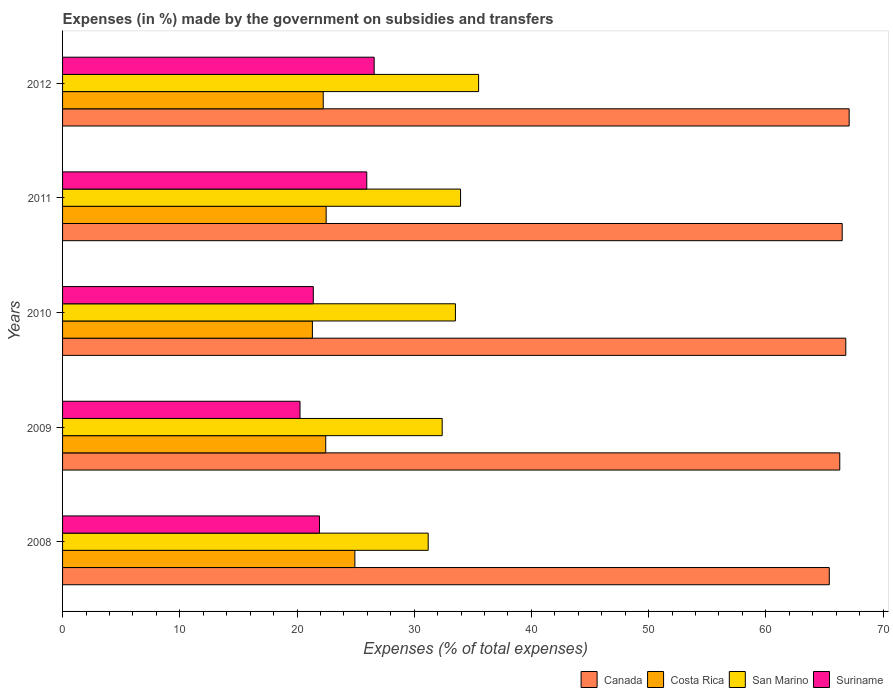How many different coloured bars are there?
Provide a succinct answer. 4. How many groups of bars are there?
Keep it short and to the point. 5. Are the number of bars per tick equal to the number of legend labels?
Keep it short and to the point. Yes. How many bars are there on the 1st tick from the bottom?
Give a very brief answer. 4. What is the percentage of expenses made by the government on subsidies and transfers in Canada in 2008?
Provide a succinct answer. 65.41. Across all years, what is the maximum percentage of expenses made by the government on subsidies and transfers in Suriname?
Provide a short and direct response. 26.58. Across all years, what is the minimum percentage of expenses made by the government on subsidies and transfers in Costa Rica?
Your answer should be very brief. 21.31. What is the total percentage of expenses made by the government on subsidies and transfers in San Marino in the graph?
Provide a succinct answer. 166.54. What is the difference between the percentage of expenses made by the government on subsidies and transfers in Costa Rica in 2011 and that in 2012?
Make the answer very short. 0.25. What is the difference between the percentage of expenses made by the government on subsidies and transfers in Canada in 2010 and the percentage of expenses made by the government on subsidies and transfers in San Marino in 2011?
Keep it short and to the point. 32.86. What is the average percentage of expenses made by the government on subsidies and transfers in Canada per year?
Offer a very short reply. 66.43. In the year 2012, what is the difference between the percentage of expenses made by the government on subsidies and transfers in Canada and percentage of expenses made by the government on subsidies and transfers in Costa Rica?
Your answer should be compact. 44.87. What is the ratio of the percentage of expenses made by the government on subsidies and transfers in Canada in 2009 to that in 2010?
Keep it short and to the point. 0.99. Is the percentage of expenses made by the government on subsidies and transfers in San Marino in 2008 less than that in 2012?
Ensure brevity in your answer.  Yes. Is the difference between the percentage of expenses made by the government on subsidies and transfers in Canada in 2008 and 2012 greater than the difference between the percentage of expenses made by the government on subsidies and transfers in Costa Rica in 2008 and 2012?
Your answer should be very brief. No. What is the difference between the highest and the second highest percentage of expenses made by the government on subsidies and transfers in Suriname?
Your answer should be very brief. 0.63. What is the difference between the highest and the lowest percentage of expenses made by the government on subsidies and transfers in Canada?
Offer a terse response. 1.7. In how many years, is the percentage of expenses made by the government on subsidies and transfers in Costa Rica greater than the average percentage of expenses made by the government on subsidies and transfers in Costa Rica taken over all years?
Provide a short and direct response. 1. Is it the case that in every year, the sum of the percentage of expenses made by the government on subsidies and transfers in Canada and percentage of expenses made by the government on subsidies and transfers in Suriname is greater than the percentage of expenses made by the government on subsidies and transfers in Costa Rica?
Give a very brief answer. Yes. How many bars are there?
Ensure brevity in your answer.  20. How many years are there in the graph?
Offer a terse response. 5. What is the difference between two consecutive major ticks on the X-axis?
Give a very brief answer. 10. Are the values on the major ticks of X-axis written in scientific E-notation?
Your answer should be very brief. No. Does the graph contain grids?
Your answer should be very brief. No. What is the title of the graph?
Offer a terse response. Expenses (in %) made by the government on subsidies and transfers. What is the label or title of the X-axis?
Offer a very short reply. Expenses (% of total expenses). What is the label or title of the Y-axis?
Keep it short and to the point. Years. What is the Expenses (% of total expenses) in Canada in 2008?
Your answer should be very brief. 65.41. What is the Expenses (% of total expenses) of Costa Rica in 2008?
Provide a succinct answer. 24.94. What is the Expenses (% of total expenses) of San Marino in 2008?
Provide a short and direct response. 31.19. What is the Expenses (% of total expenses) in Suriname in 2008?
Keep it short and to the point. 21.92. What is the Expenses (% of total expenses) of Canada in 2009?
Provide a succinct answer. 66.3. What is the Expenses (% of total expenses) in Costa Rica in 2009?
Provide a succinct answer. 22.45. What is the Expenses (% of total expenses) in San Marino in 2009?
Your answer should be compact. 32.39. What is the Expenses (% of total expenses) of Suriname in 2009?
Keep it short and to the point. 20.26. What is the Expenses (% of total expenses) in Canada in 2010?
Offer a very short reply. 66.82. What is the Expenses (% of total expenses) of Costa Rica in 2010?
Give a very brief answer. 21.31. What is the Expenses (% of total expenses) of San Marino in 2010?
Offer a terse response. 33.52. What is the Expenses (% of total expenses) in Suriname in 2010?
Make the answer very short. 21.39. What is the Expenses (% of total expenses) of Canada in 2011?
Offer a terse response. 66.51. What is the Expenses (% of total expenses) of Costa Rica in 2011?
Ensure brevity in your answer.  22.49. What is the Expenses (% of total expenses) of San Marino in 2011?
Your answer should be very brief. 33.95. What is the Expenses (% of total expenses) in Suriname in 2011?
Offer a very short reply. 25.95. What is the Expenses (% of total expenses) in Canada in 2012?
Your answer should be compact. 67.11. What is the Expenses (% of total expenses) of Costa Rica in 2012?
Ensure brevity in your answer.  22.24. What is the Expenses (% of total expenses) of San Marino in 2012?
Your answer should be compact. 35.49. What is the Expenses (% of total expenses) in Suriname in 2012?
Offer a very short reply. 26.58. Across all years, what is the maximum Expenses (% of total expenses) of Canada?
Your answer should be very brief. 67.11. Across all years, what is the maximum Expenses (% of total expenses) in Costa Rica?
Offer a very short reply. 24.94. Across all years, what is the maximum Expenses (% of total expenses) in San Marino?
Offer a terse response. 35.49. Across all years, what is the maximum Expenses (% of total expenses) of Suriname?
Give a very brief answer. 26.58. Across all years, what is the minimum Expenses (% of total expenses) of Canada?
Keep it short and to the point. 65.41. Across all years, what is the minimum Expenses (% of total expenses) in Costa Rica?
Make the answer very short. 21.31. Across all years, what is the minimum Expenses (% of total expenses) in San Marino?
Keep it short and to the point. 31.19. Across all years, what is the minimum Expenses (% of total expenses) in Suriname?
Make the answer very short. 20.26. What is the total Expenses (% of total expenses) of Canada in the graph?
Keep it short and to the point. 332.15. What is the total Expenses (% of total expenses) of Costa Rica in the graph?
Keep it short and to the point. 113.43. What is the total Expenses (% of total expenses) in San Marino in the graph?
Offer a very short reply. 166.54. What is the total Expenses (% of total expenses) in Suriname in the graph?
Make the answer very short. 116.1. What is the difference between the Expenses (% of total expenses) in Canada in 2008 and that in 2009?
Your answer should be very brief. -0.89. What is the difference between the Expenses (% of total expenses) in Costa Rica in 2008 and that in 2009?
Make the answer very short. 2.49. What is the difference between the Expenses (% of total expenses) of San Marino in 2008 and that in 2009?
Provide a short and direct response. -1.19. What is the difference between the Expenses (% of total expenses) of Suriname in 2008 and that in 2009?
Provide a succinct answer. 1.66. What is the difference between the Expenses (% of total expenses) in Canada in 2008 and that in 2010?
Offer a terse response. -1.41. What is the difference between the Expenses (% of total expenses) of Costa Rica in 2008 and that in 2010?
Offer a very short reply. 3.62. What is the difference between the Expenses (% of total expenses) of San Marino in 2008 and that in 2010?
Offer a terse response. -2.32. What is the difference between the Expenses (% of total expenses) of Suriname in 2008 and that in 2010?
Ensure brevity in your answer.  0.53. What is the difference between the Expenses (% of total expenses) in Canada in 2008 and that in 2011?
Make the answer very short. -1.1. What is the difference between the Expenses (% of total expenses) of Costa Rica in 2008 and that in 2011?
Your answer should be very brief. 2.45. What is the difference between the Expenses (% of total expenses) of San Marino in 2008 and that in 2011?
Offer a terse response. -2.76. What is the difference between the Expenses (% of total expenses) of Suriname in 2008 and that in 2011?
Provide a short and direct response. -4.03. What is the difference between the Expenses (% of total expenses) of Canada in 2008 and that in 2012?
Your answer should be compact. -1.7. What is the difference between the Expenses (% of total expenses) in Costa Rica in 2008 and that in 2012?
Offer a very short reply. 2.7. What is the difference between the Expenses (% of total expenses) of San Marino in 2008 and that in 2012?
Make the answer very short. -4.3. What is the difference between the Expenses (% of total expenses) of Suriname in 2008 and that in 2012?
Offer a terse response. -4.67. What is the difference between the Expenses (% of total expenses) of Canada in 2009 and that in 2010?
Your answer should be compact. -0.51. What is the difference between the Expenses (% of total expenses) in Costa Rica in 2009 and that in 2010?
Offer a very short reply. 1.14. What is the difference between the Expenses (% of total expenses) of San Marino in 2009 and that in 2010?
Provide a succinct answer. -1.13. What is the difference between the Expenses (% of total expenses) in Suriname in 2009 and that in 2010?
Give a very brief answer. -1.13. What is the difference between the Expenses (% of total expenses) of Canada in 2009 and that in 2011?
Provide a succinct answer. -0.21. What is the difference between the Expenses (% of total expenses) of Costa Rica in 2009 and that in 2011?
Your response must be concise. -0.04. What is the difference between the Expenses (% of total expenses) in San Marino in 2009 and that in 2011?
Offer a terse response. -1.57. What is the difference between the Expenses (% of total expenses) of Suriname in 2009 and that in 2011?
Keep it short and to the point. -5.69. What is the difference between the Expenses (% of total expenses) in Canada in 2009 and that in 2012?
Offer a terse response. -0.8. What is the difference between the Expenses (% of total expenses) of Costa Rica in 2009 and that in 2012?
Offer a terse response. 0.21. What is the difference between the Expenses (% of total expenses) of San Marino in 2009 and that in 2012?
Your answer should be very brief. -3.11. What is the difference between the Expenses (% of total expenses) of Suriname in 2009 and that in 2012?
Give a very brief answer. -6.33. What is the difference between the Expenses (% of total expenses) in Canada in 2010 and that in 2011?
Provide a short and direct response. 0.31. What is the difference between the Expenses (% of total expenses) of Costa Rica in 2010 and that in 2011?
Make the answer very short. -1.17. What is the difference between the Expenses (% of total expenses) of San Marino in 2010 and that in 2011?
Give a very brief answer. -0.44. What is the difference between the Expenses (% of total expenses) in Suriname in 2010 and that in 2011?
Give a very brief answer. -4.56. What is the difference between the Expenses (% of total expenses) in Canada in 2010 and that in 2012?
Your response must be concise. -0.29. What is the difference between the Expenses (% of total expenses) of Costa Rica in 2010 and that in 2012?
Your answer should be compact. -0.92. What is the difference between the Expenses (% of total expenses) in San Marino in 2010 and that in 2012?
Give a very brief answer. -1.98. What is the difference between the Expenses (% of total expenses) of Suriname in 2010 and that in 2012?
Offer a terse response. -5.19. What is the difference between the Expenses (% of total expenses) in Canada in 2011 and that in 2012?
Keep it short and to the point. -0.59. What is the difference between the Expenses (% of total expenses) of Costa Rica in 2011 and that in 2012?
Offer a very short reply. 0.25. What is the difference between the Expenses (% of total expenses) in San Marino in 2011 and that in 2012?
Provide a succinct answer. -1.54. What is the difference between the Expenses (% of total expenses) in Suriname in 2011 and that in 2012?
Keep it short and to the point. -0.63. What is the difference between the Expenses (% of total expenses) in Canada in 2008 and the Expenses (% of total expenses) in Costa Rica in 2009?
Provide a short and direct response. 42.96. What is the difference between the Expenses (% of total expenses) of Canada in 2008 and the Expenses (% of total expenses) of San Marino in 2009?
Keep it short and to the point. 33.02. What is the difference between the Expenses (% of total expenses) of Canada in 2008 and the Expenses (% of total expenses) of Suriname in 2009?
Your response must be concise. 45.15. What is the difference between the Expenses (% of total expenses) of Costa Rica in 2008 and the Expenses (% of total expenses) of San Marino in 2009?
Make the answer very short. -7.45. What is the difference between the Expenses (% of total expenses) of Costa Rica in 2008 and the Expenses (% of total expenses) of Suriname in 2009?
Ensure brevity in your answer.  4.68. What is the difference between the Expenses (% of total expenses) of San Marino in 2008 and the Expenses (% of total expenses) of Suriname in 2009?
Offer a terse response. 10.94. What is the difference between the Expenses (% of total expenses) in Canada in 2008 and the Expenses (% of total expenses) in Costa Rica in 2010?
Your response must be concise. 44.1. What is the difference between the Expenses (% of total expenses) of Canada in 2008 and the Expenses (% of total expenses) of San Marino in 2010?
Keep it short and to the point. 31.9. What is the difference between the Expenses (% of total expenses) of Canada in 2008 and the Expenses (% of total expenses) of Suriname in 2010?
Provide a short and direct response. 44.02. What is the difference between the Expenses (% of total expenses) in Costa Rica in 2008 and the Expenses (% of total expenses) in San Marino in 2010?
Provide a short and direct response. -8.58. What is the difference between the Expenses (% of total expenses) of Costa Rica in 2008 and the Expenses (% of total expenses) of Suriname in 2010?
Your answer should be compact. 3.55. What is the difference between the Expenses (% of total expenses) in San Marino in 2008 and the Expenses (% of total expenses) in Suriname in 2010?
Keep it short and to the point. 9.8. What is the difference between the Expenses (% of total expenses) of Canada in 2008 and the Expenses (% of total expenses) of Costa Rica in 2011?
Your response must be concise. 42.92. What is the difference between the Expenses (% of total expenses) in Canada in 2008 and the Expenses (% of total expenses) in San Marino in 2011?
Make the answer very short. 31.46. What is the difference between the Expenses (% of total expenses) in Canada in 2008 and the Expenses (% of total expenses) in Suriname in 2011?
Your response must be concise. 39.46. What is the difference between the Expenses (% of total expenses) of Costa Rica in 2008 and the Expenses (% of total expenses) of San Marino in 2011?
Your answer should be very brief. -9.02. What is the difference between the Expenses (% of total expenses) of Costa Rica in 2008 and the Expenses (% of total expenses) of Suriname in 2011?
Keep it short and to the point. -1.01. What is the difference between the Expenses (% of total expenses) of San Marino in 2008 and the Expenses (% of total expenses) of Suriname in 2011?
Your answer should be very brief. 5.24. What is the difference between the Expenses (% of total expenses) in Canada in 2008 and the Expenses (% of total expenses) in Costa Rica in 2012?
Offer a very short reply. 43.17. What is the difference between the Expenses (% of total expenses) of Canada in 2008 and the Expenses (% of total expenses) of San Marino in 2012?
Offer a very short reply. 29.92. What is the difference between the Expenses (% of total expenses) of Canada in 2008 and the Expenses (% of total expenses) of Suriname in 2012?
Give a very brief answer. 38.83. What is the difference between the Expenses (% of total expenses) in Costa Rica in 2008 and the Expenses (% of total expenses) in San Marino in 2012?
Ensure brevity in your answer.  -10.56. What is the difference between the Expenses (% of total expenses) of Costa Rica in 2008 and the Expenses (% of total expenses) of Suriname in 2012?
Give a very brief answer. -1.65. What is the difference between the Expenses (% of total expenses) of San Marino in 2008 and the Expenses (% of total expenses) of Suriname in 2012?
Give a very brief answer. 4.61. What is the difference between the Expenses (% of total expenses) of Canada in 2009 and the Expenses (% of total expenses) of Costa Rica in 2010?
Your response must be concise. 44.99. What is the difference between the Expenses (% of total expenses) of Canada in 2009 and the Expenses (% of total expenses) of San Marino in 2010?
Keep it short and to the point. 32.79. What is the difference between the Expenses (% of total expenses) of Canada in 2009 and the Expenses (% of total expenses) of Suriname in 2010?
Give a very brief answer. 44.91. What is the difference between the Expenses (% of total expenses) of Costa Rica in 2009 and the Expenses (% of total expenses) of San Marino in 2010?
Provide a succinct answer. -11.06. What is the difference between the Expenses (% of total expenses) in Costa Rica in 2009 and the Expenses (% of total expenses) in Suriname in 2010?
Offer a terse response. 1.06. What is the difference between the Expenses (% of total expenses) in San Marino in 2009 and the Expenses (% of total expenses) in Suriname in 2010?
Offer a very short reply. 10.99. What is the difference between the Expenses (% of total expenses) in Canada in 2009 and the Expenses (% of total expenses) in Costa Rica in 2011?
Provide a short and direct response. 43.82. What is the difference between the Expenses (% of total expenses) of Canada in 2009 and the Expenses (% of total expenses) of San Marino in 2011?
Your answer should be compact. 32.35. What is the difference between the Expenses (% of total expenses) in Canada in 2009 and the Expenses (% of total expenses) in Suriname in 2011?
Provide a succinct answer. 40.35. What is the difference between the Expenses (% of total expenses) in Costa Rica in 2009 and the Expenses (% of total expenses) in San Marino in 2011?
Offer a very short reply. -11.5. What is the difference between the Expenses (% of total expenses) in Costa Rica in 2009 and the Expenses (% of total expenses) in Suriname in 2011?
Provide a succinct answer. -3.5. What is the difference between the Expenses (% of total expenses) of San Marino in 2009 and the Expenses (% of total expenses) of Suriname in 2011?
Your answer should be very brief. 6.43. What is the difference between the Expenses (% of total expenses) in Canada in 2009 and the Expenses (% of total expenses) in Costa Rica in 2012?
Give a very brief answer. 44.07. What is the difference between the Expenses (% of total expenses) in Canada in 2009 and the Expenses (% of total expenses) in San Marino in 2012?
Offer a very short reply. 30.81. What is the difference between the Expenses (% of total expenses) of Canada in 2009 and the Expenses (% of total expenses) of Suriname in 2012?
Offer a very short reply. 39.72. What is the difference between the Expenses (% of total expenses) in Costa Rica in 2009 and the Expenses (% of total expenses) in San Marino in 2012?
Keep it short and to the point. -13.04. What is the difference between the Expenses (% of total expenses) of Costa Rica in 2009 and the Expenses (% of total expenses) of Suriname in 2012?
Your answer should be compact. -4.13. What is the difference between the Expenses (% of total expenses) of San Marino in 2009 and the Expenses (% of total expenses) of Suriname in 2012?
Ensure brevity in your answer.  5.8. What is the difference between the Expenses (% of total expenses) in Canada in 2010 and the Expenses (% of total expenses) in Costa Rica in 2011?
Your response must be concise. 44.33. What is the difference between the Expenses (% of total expenses) of Canada in 2010 and the Expenses (% of total expenses) of San Marino in 2011?
Your answer should be very brief. 32.86. What is the difference between the Expenses (% of total expenses) of Canada in 2010 and the Expenses (% of total expenses) of Suriname in 2011?
Provide a short and direct response. 40.87. What is the difference between the Expenses (% of total expenses) of Costa Rica in 2010 and the Expenses (% of total expenses) of San Marino in 2011?
Your answer should be very brief. -12.64. What is the difference between the Expenses (% of total expenses) in Costa Rica in 2010 and the Expenses (% of total expenses) in Suriname in 2011?
Keep it short and to the point. -4.64. What is the difference between the Expenses (% of total expenses) in San Marino in 2010 and the Expenses (% of total expenses) in Suriname in 2011?
Provide a short and direct response. 7.56. What is the difference between the Expenses (% of total expenses) of Canada in 2010 and the Expenses (% of total expenses) of Costa Rica in 2012?
Provide a succinct answer. 44.58. What is the difference between the Expenses (% of total expenses) in Canada in 2010 and the Expenses (% of total expenses) in San Marino in 2012?
Your response must be concise. 31.32. What is the difference between the Expenses (% of total expenses) of Canada in 2010 and the Expenses (% of total expenses) of Suriname in 2012?
Keep it short and to the point. 40.23. What is the difference between the Expenses (% of total expenses) of Costa Rica in 2010 and the Expenses (% of total expenses) of San Marino in 2012?
Your answer should be compact. -14.18. What is the difference between the Expenses (% of total expenses) in Costa Rica in 2010 and the Expenses (% of total expenses) in Suriname in 2012?
Keep it short and to the point. -5.27. What is the difference between the Expenses (% of total expenses) of San Marino in 2010 and the Expenses (% of total expenses) of Suriname in 2012?
Give a very brief answer. 6.93. What is the difference between the Expenses (% of total expenses) of Canada in 2011 and the Expenses (% of total expenses) of Costa Rica in 2012?
Offer a very short reply. 44.27. What is the difference between the Expenses (% of total expenses) in Canada in 2011 and the Expenses (% of total expenses) in San Marino in 2012?
Make the answer very short. 31.02. What is the difference between the Expenses (% of total expenses) of Canada in 2011 and the Expenses (% of total expenses) of Suriname in 2012?
Provide a short and direct response. 39.93. What is the difference between the Expenses (% of total expenses) in Costa Rica in 2011 and the Expenses (% of total expenses) in San Marino in 2012?
Give a very brief answer. -13.01. What is the difference between the Expenses (% of total expenses) of Costa Rica in 2011 and the Expenses (% of total expenses) of Suriname in 2012?
Your answer should be very brief. -4.1. What is the difference between the Expenses (% of total expenses) of San Marino in 2011 and the Expenses (% of total expenses) of Suriname in 2012?
Offer a terse response. 7.37. What is the average Expenses (% of total expenses) of Canada per year?
Make the answer very short. 66.43. What is the average Expenses (% of total expenses) of Costa Rica per year?
Your answer should be compact. 22.69. What is the average Expenses (% of total expenses) in San Marino per year?
Your response must be concise. 33.31. What is the average Expenses (% of total expenses) in Suriname per year?
Offer a very short reply. 23.22. In the year 2008, what is the difference between the Expenses (% of total expenses) of Canada and Expenses (% of total expenses) of Costa Rica?
Your answer should be compact. 40.47. In the year 2008, what is the difference between the Expenses (% of total expenses) of Canada and Expenses (% of total expenses) of San Marino?
Give a very brief answer. 34.22. In the year 2008, what is the difference between the Expenses (% of total expenses) in Canada and Expenses (% of total expenses) in Suriname?
Your response must be concise. 43.49. In the year 2008, what is the difference between the Expenses (% of total expenses) of Costa Rica and Expenses (% of total expenses) of San Marino?
Your answer should be compact. -6.25. In the year 2008, what is the difference between the Expenses (% of total expenses) in Costa Rica and Expenses (% of total expenses) in Suriname?
Provide a succinct answer. 3.02. In the year 2008, what is the difference between the Expenses (% of total expenses) in San Marino and Expenses (% of total expenses) in Suriname?
Keep it short and to the point. 9.27. In the year 2009, what is the difference between the Expenses (% of total expenses) in Canada and Expenses (% of total expenses) in Costa Rica?
Provide a succinct answer. 43.85. In the year 2009, what is the difference between the Expenses (% of total expenses) in Canada and Expenses (% of total expenses) in San Marino?
Offer a terse response. 33.92. In the year 2009, what is the difference between the Expenses (% of total expenses) in Canada and Expenses (% of total expenses) in Suriname?
Provide a succinct answer. 46.05. In the year 2009, what is the difference between the Expenses (% of total expenses) in Costa Rica and Expenses (% of total expenses) in San Marino?
Offer a very short reply. -9.94. In the year 2009, what is the difference between the Expenses (% of total expenses) in Costa Rica and Expenses (% of total expenses) in Suriname?
Make the answer very short. 2.19. In the year 2009, what is the difference between the Expenses (% of total expenses) of San Marino and Expenses (% of total expenses) of Suriname?
Provide a short and direct response. 12.13. In the year 2010, what is the difference between the Expenses (% of total expenses) of Canada and Expenses (% of total expenses) of Costa Rica?
Ensure brevity in your answer.  45.5. In the year 2010, what is the difference between the Expenses (% of total expenses) in Canada and Expenses (% of total expenses) in San Marino?
Provide a succinct answer. 33.3. In the year 2010, what is the difference between the Expenses (% of total expenses) in Canada and Expenses (% of total expenses) in Suriname?
Your answer should be compact. 45.43. In the year 2010, what is the difference between the Expenses (% of total expenses) in Costa Rica and Expenses (% of total expenses) in San Marino?
Your answer should be very brief. -12.2. In the year 2010, what is the difference between the Expenses (% of total expenses) of Costa Rica and Expenses (% of total expenses) of Suriname?
Provide a succinct answer. -0.08. In the year 2010, what is the difference between the Expenses (% of total expenses) of San Marino and Expenses (% of total expenses) of Suriname?
Your answer should be compact. 12.12. In the year 2011, what is the difference between the Expenses (% of total expenses) of Canada and Expenses (% of total expenses) of Costa Rica?
Provide a short and direct response. 44.03. In the year 2011, what is the difference between the Expenses (% of total expenses) in Canada and Expenses (% of total expenses) in San Marino?
Offer a very short reply. 32.56. In the year 2011, what is the difference between the Expenses (% of total expenses) in Canada and Expenses (% of total expenses) in Suriname?
Ensure brevity in your answer.  40.56. In the year 2011, what is the difference between the Expenses (% of total expenses) in Costa Rica and Expenses (% of total expenses) in San Marino?
Your response must be concise. -11.47. In the year 2011, what is the difference between the Expenses (% of total expenses) of Costa Rica and Expenses (% of total expenses) of Suriname?
Offer a terse response. -3.46. In the year 2011, what is the difference between the Expenses (% of total expenses) in San Marino and Expenses (% of total expenses) in Suriname?
Offer a very short reply. 8. In the year 2012, what is the difference between the Expenses (% of total expenses) of Canada and Expenses (% of total expenses) of Costa Rica?
Your answer should be compact. 44.87. In the year 2012, what is the difference between the Expenses (% of total expenses) of Canada and Expenses (% of total expenses) of San Marino?
Ensure brevity in your answer.  31.61. In the year 2012, what is the difference between the Expenses (% of total expenses) of Canada and Expenses (% of total expenses) of Suriname?
Ensure brevity in your answer.  40.52. In the year 2012, what is the difference between the Expenses (% of total expenses) in Costa Rica and Expenses (% of total expenses) in San Marino?
Provide a short and direct response. -13.26. In the year 2012, what is the difference between the Expenses (% of total expenses) in Costa Rica and Expenses (% of total expenses) in Suriname?
Provide a succinct answer. -4.35. In the year 2012, what is the difference between the Expenses (% of total expenses) in San Marino and Expenses (% of total expenses) in Suriname?
Your response must be concise. 8.91. What is the ratio of the Expenses (% of total expenses) of Canada in 2008 to that in 2009?
Keep it short and to the point. 0.99. What is the ratio of the Expenses (% of total expenses) of Costa Rica in 2008 to that in 2009?
Keep it short and to the point. 1.11. What is the ratio of the Expenses (% of total expenses) of San Marino in 2008 to that in 2009?
Your answer should be compact. 0.96. What is the ratio of the Expenses (% of total expenses) of Suriname in 2008 to that in 2009?
Offer a very short reply. 1.08. What is the ratio of the Expenses (% of total expenses) of Canada in 2008 to that in 2010?
Offer a terse response. 0.98. What is the ratio of the Expenses (% of total expenses) of Costa Rica in 2008 to that in 2010?
Your answer should be compact. 1.17. What is the ratio of the Expenses (% of total expenses) of San Marino in 2008 to that in 2010?
Your response must be concise. 0.93. What is the ratio of the Expenses (% of total expenses) of Suriname in 2008 to that in 2010?
Give a very brief answer. 1.02. What is the ratio of the Expenses (% of total expenses) in Canada in 2008 to that in 2011?
Keep it short and to the point. 0.98. What is the ratio of the Expenses (% of total expenses) in Costa Rica in 2008 to that in 2011?
Your response must be concise. 1.11. What is the ratio of the Expenses (% of total expenses) of San Marino in 2008 to that in 2011?
Your response must be concise. 0.92. What is the ratio of the Expenses (% of total expenses) in Suriname in 2008 to that in 2011?
Your answer should be very brief. 0.84. What is the ratio of the Expenses (% of total expenses) in Canada in 2008 to that in 2012?
Your answer should be compact. 0.97. What is the ratio of the Expenses (% of total expenses) in Costa Rica in 2008 to that in 2012?
Your response must be concise. 1.12. What is the ratio of the Expenses (% of total expenses) of San Marino in 2008 to that in 2012?
Make the answer very short. 0.88. What is the ratio of the Expenses (% of total expenses) of Suriname in 2008 to that in 2012?
Provide a succinct answer. 0.82. What is the ratio of the Expenses (% of total expenses) in Costa Rica in 2009 to that in 2010?
Keep it short and to the point. 1.05. What is the ratio of the Expenses (% of total expenses) of San Marino in 2009 to that in 2010?
Your answer should be compact. 0.97. What is the ratio of the Expenses (% of total expenses) in Suriname in 2009 to that in 2010?
Offer a terse response. 0.95. What is the ratio of the Expenses (% of total expenses) in Canada in 2009 to that in 2011?
Offer a terse response. 1. What is the ratio of the Expenses (% of total expenses) of San Marino in 2009 to that in 2011?
Your answer should be compact. 0.95. What is the ratio of the Expenses (% of total expenses) of Suriname in 2009 to that in 2011?
Provide a succinct answer. 0.78. What is the ratio of the Expenses (% of total expenses) of Canada in 2009 to that in 2012?
Give a very brief answer. 0.99. What is the ratio of the Expenses (% of total expenses) of Costa Rica in 2009 to that in 2012?
Your response must be concise. 1.01. What is the ratio of the Expenses (% of total expenses) of San Marino in 2009 to that in 2012?
Your response must be concise. 0.91. What is the ratio of the Expenses (% of total expenses) of Suriname in 2009 to that in 2012?
Your response must be concise. 0.76. What is the ratio of the Expenses (% of total expenses) of Canada in 2010 to that in 2011?
Provide a short and direct response. 1. What is the ratio of the Expenses (% of total expenses) of Costa Rica in 2010 to that in 2011?
Provide a succinct answer. 0.95. What is the ratio of the Expenses (% of total expenses) of San Marino in 2010 to that in 2011?
Offer a very short reply. 0.99. What is the ratio of the Expenses (% of total expenses) of Suriname in 2010 to that in 2011?
Offer a very short reply. 0.82. What is the ratio of the Expenses (% of total expenses) in Canada in 2010 to that in 2012?
Offer a very short reply. 1. What is the ratio of the Expenses (% of total expenses) of Costa Rica in 2010 to that in 2012?
Offer a terse response. 0.96. What is the ratio of the Expenses (% of total expenses) of San Marino in 2010 to that in 2012?
Your response must be concise. 0.94. What is the ratio of the Expenses (% of total expenses) of Suriname in 2010 to that in 2012?
Give a very brief answer. 0.8. What is the ratio of the Expenses (% of total expenses) of Canada in 2011 to that in 2012?
Ensure brevity in your answer.  0.99. What is the ratio of the Expenses (% of total expenses) in Costa Rica in 2011 to that in 2012?
Offer a terse response. 1.01. What is the ratio of the Expenses (% of total expenses) of San Marino in 2011 to that in 2012?
Offer a terse response. 0.96. What is the ratio of the Expenses (% of total expenses) of Suriname in 2011 to that in 2012?
Provide a short and direct response. 0.98. What is the difference between the highest and the second highest Expenses (% of total expenses) in Canada?
Keep it short and to the point. 0.29. What is the difference between the highest and the second highest Expenses (% of total expenses) in Costa Rica?
Offer a terse response. 2.45. What is the difference between the highest and the second highest Expenses (% of total expenses) of San Marino?
Give a very brief answer. 1.54. What is the difference between the highest and the second highest Expenses (% of total expenses) of Suriname?
Provide a succinct answer. 0.63. What is the difference between the highest and the lowest Expenses (% of total expenses) in Canada?
Keep it short and to the point. 1.7. What is the difference between the highest and the lowest Expenses (% of total expenses) of Costa Rica?
Ensure brevity in your answer.  3.62. What is the difference between the highest and the lowest Expenses (% of total expenses) of San Marino?
Provide a short and direct response. 4.3. What is the difference between the highest and the lowest Expenses (% of total expenses) in Suriname?
Give a very brief answer. 6.33. 